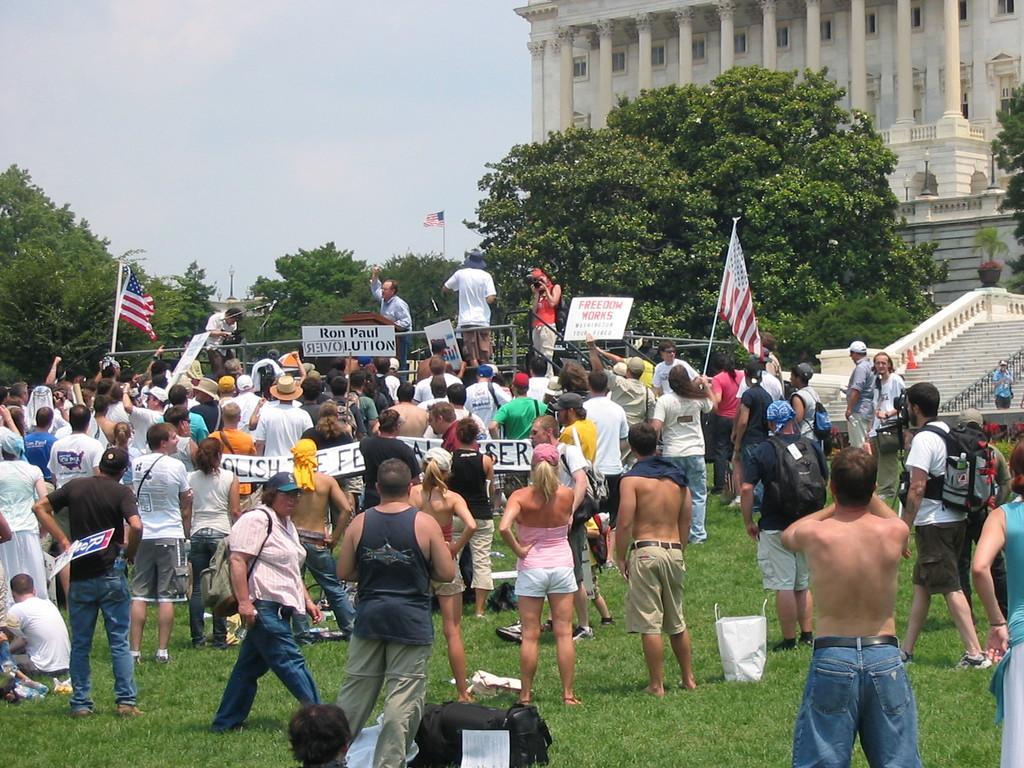Please provide a concise description of this image. It looks like a protest, there are a lot of people standing in front of an organisation and they are holding different types of banners and flags, behind the people there are a lot of trees. 